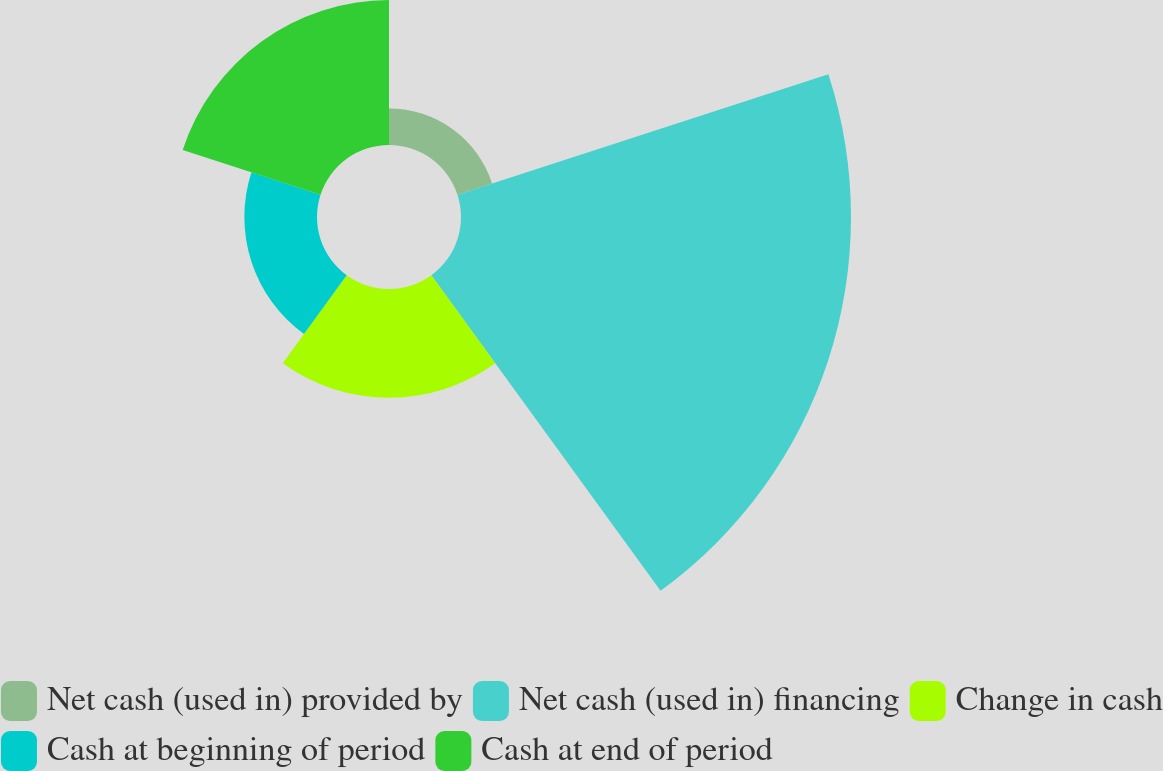<chart> <loc_0><loc_0><loc_500><loc_500><pie_chart><fcel>Net cash (used in) provided by<fcel>Net cash (used in) financing<fcel>Change in cash<fcel>Cash at beginning of period<fcel>Cash at end of period<nl><fcel>4.84%<fcel>51.81%<fcel>14.45%<fcel>9.65%<fcel>19.25%<nl></chart> 